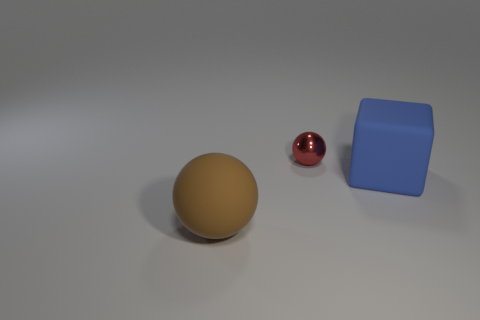Add 2 small red metal balls. How many objects exist? 5 Subtract all blocks. How many objects are left? 2 Add 1 small gray shiny spheres. How many small gray shiny spheres exist? 1 Subtract 0 purple spheres. How many objects are left? 3 Subtract all red metallic spheres. Subtract all large cylinders. How many objects are left? 2 Add 3 spheres. How many spheres are left? 5 